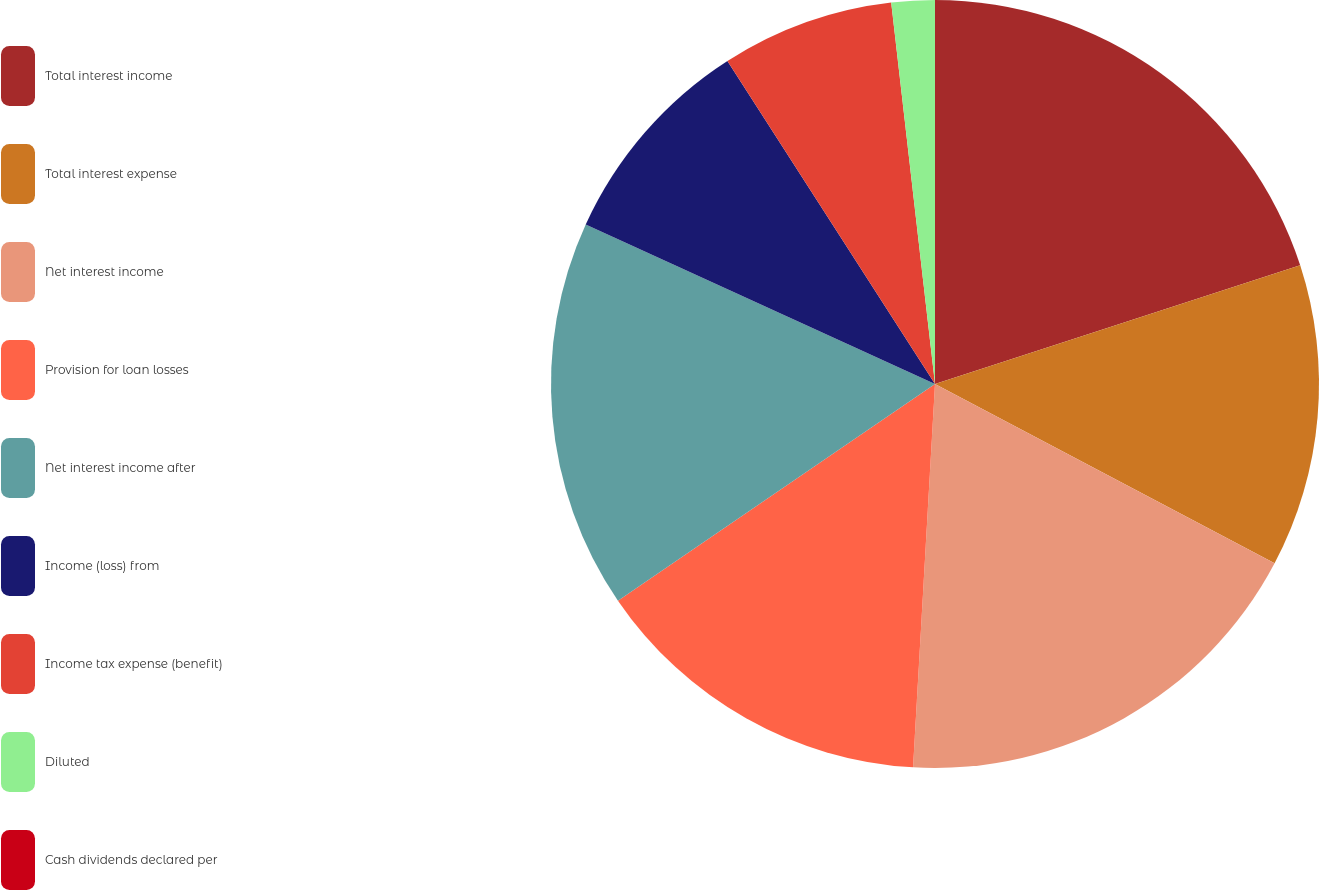<chart> <loc_0><loc_0><loc_500><loc_500><pie_chart><fcel>Total interest income<fcel>Total interest expense<fcel>Net interest income<fcel>Provision for loan losses<fcel>Net interest income after<fcel>Income (loss) from<fcel>Income tax expense (benefit)<fcel>Diluted<fcel>Cash dividends declared per<nl><fcel>20.0%<fcel>12.73%<fcel>18.18%<fcel>14.55%<fcel>16.36%<fcel>9.09%<fcel>7.27%<fcel>1.82%<fcel>0.0%<nl></chart> 